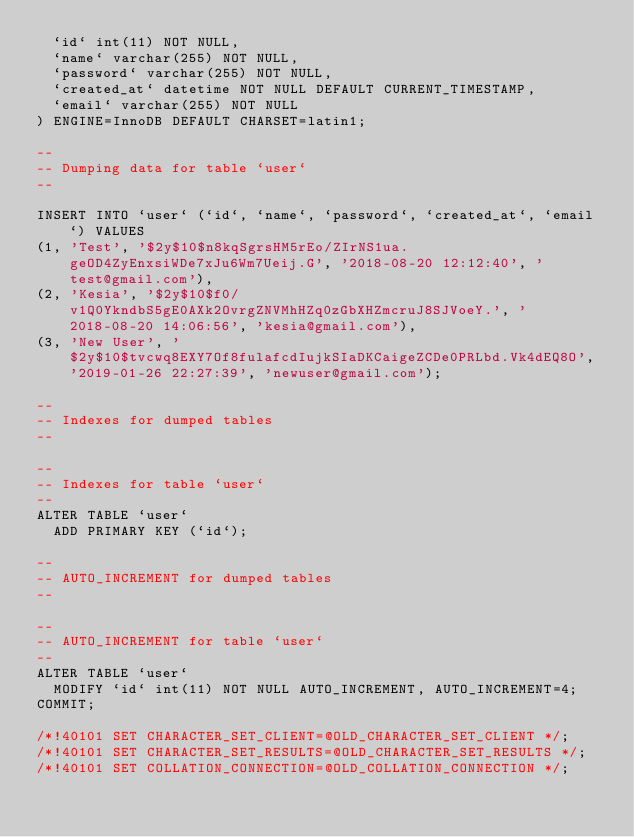Convert code to text. <code><loc_0><loc_0><loc_500><loc_500><_SQL_>  `id` int(11) NOT NULL,
  `name` varchar(255) NOT NULL,
  `password` varchar(255) NOT NULL,
  `created_at` datetime NOT NULL DEFAULT CURRENT_TIMESTAMP,
  `email` varchar(255) NOT NULL
) ENGINE=InnoDB DEFAULT CHARSET=latin1;

--
-- Dumping data for table `user`
--

INSERT INTO `user` (`id`, `name`, `password`, `created_at`, `email`) VALUES
(1, 'Test', '$2y$10$n8kqSgrsHM5rEo/ZIrNS1ua.geOD4ZyEnxsiWDe7xJu6Wm7Ueij.G', '2018-08-20 12:12:40', 'test@gmail.com'),
(2, 'Kesia', '$2y$10$f0/v1Q0YkndbS5gE0AXk2OvrgZNVMhHZq0zGbXHZmcruJ8SJVoeY.', '2018-08-20 14:06:56', 'kesia@gmail.com'),
(3, 'New User', '$2y$10$tvcwq8EXY7Of8fulafcdIujkSIaDKCaigeZCDe0PRLbd.Vk4dEQ8O', '2019-01-26 22:27:39', 'newuser@gmail.com');

--
-- Indexes for dumped tables
--

--
-- Indexes for table `user`
--
ALTER TABLE `user`
  ADD PRIMARY KEY (`id`);

--
-- AUTO_INCREMENT for dumped tables
--

--
-- AUTO_INCREMENT for table `user`
--
ALTER TABLE `user`
  MODIFY `id` int(11) NOT NULL AUTO_INCREMENT, AUTO_INCREMENT=4;
COMMIT;

/*!40101 SET CHARACTER_SET_CLIENT=@OLD_CHARACTER_SET_CLIENT */;
/*!40101 SET CHARACTER_SET_RESULTS=@OLD_CHARACTER_SET_RESULTS */;
/*!40101 SET COLLATION_CONNECTION=@OLD_COLLATION_CONNECTION */;
</code> 